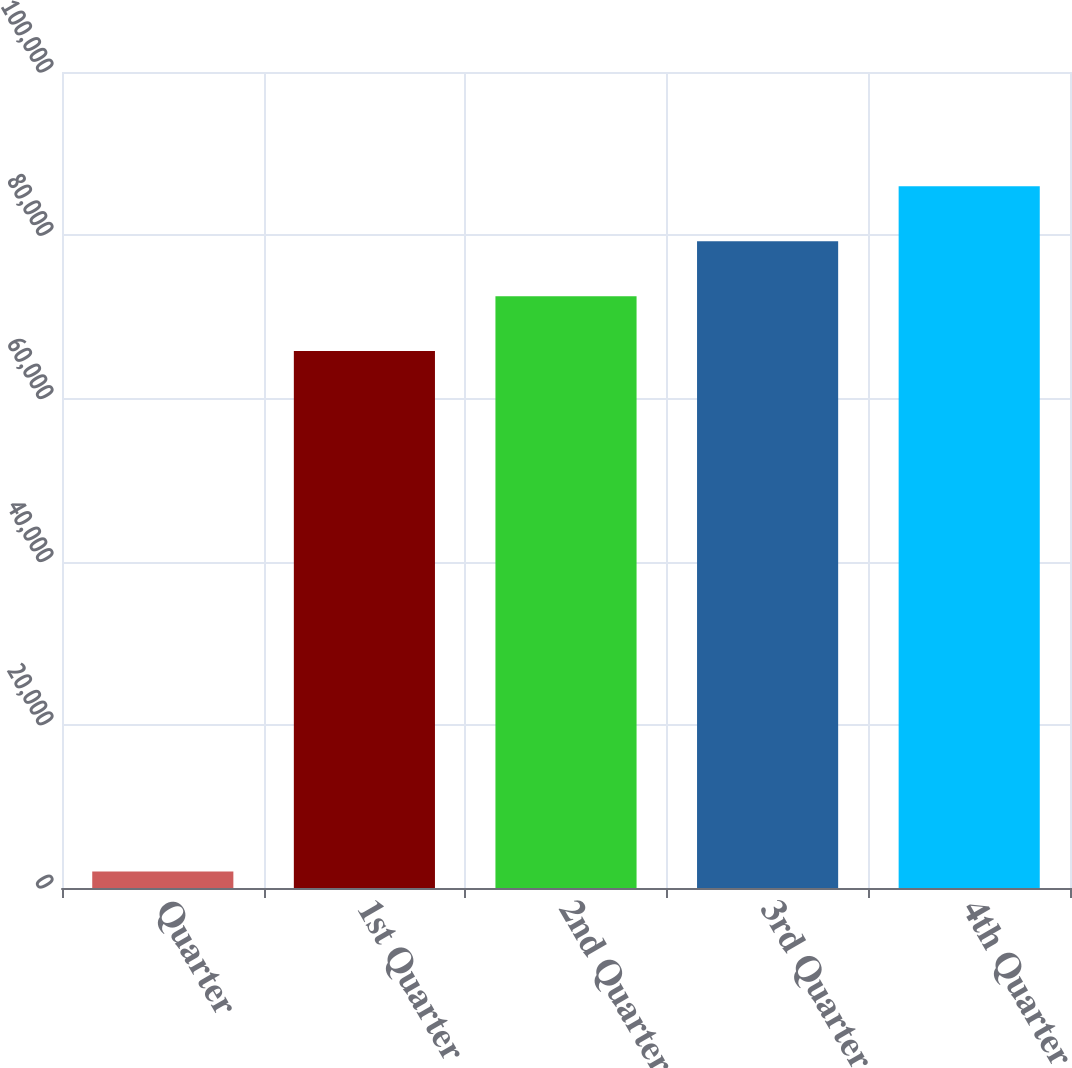<chart> <loc_0><loc_0><loc_500><loc_500><bar_chart><fcel>Quarter<fcel>1st Quarter<fcel>2nd Quarter<fcel>3rd Quarter<fcel>4th Quarter<nl><fcel>2015<fcel>65800<fcel>72528.5<fcel>79257<fcel>85985.5<nl></chart> 